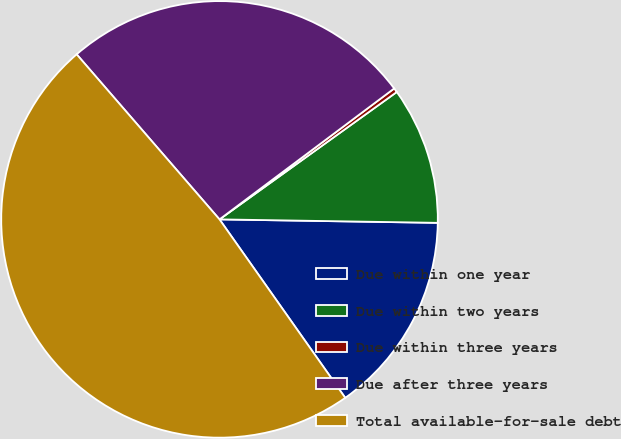<chart> <loc_0><loc_0><loc_500><loc_500><pie_chart><fcel>Due within one year<fcel>Due within two years<fcel>Due within three years<fcel>Due after three years<fcel>Total available-for-sale debt<nl><fcel>14.98%<fcel>10.17%<fcel>0.32%<fcel>26.12%<fcel>48.42%<nl></chart> 